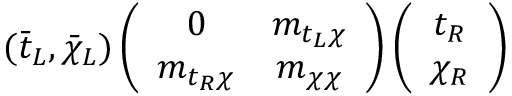<formula> <loc_0><loc_0><loc_500><loc_500>( \bar { t } _ { L } , \bar { \chi } _ { L } ) \left ( \begin{array} { c c } { 0 } & { { m _ { t _ { L } \chi } } } \\ { { m _ { t _ { R } \chi } } } & { { m _ { \chi \chi } } } \end{array} \right ) \left ( \begin{array} { c } { { t _ { R } } } \\ { { \chi _ { R } } } \end{array} \right )</formula> 